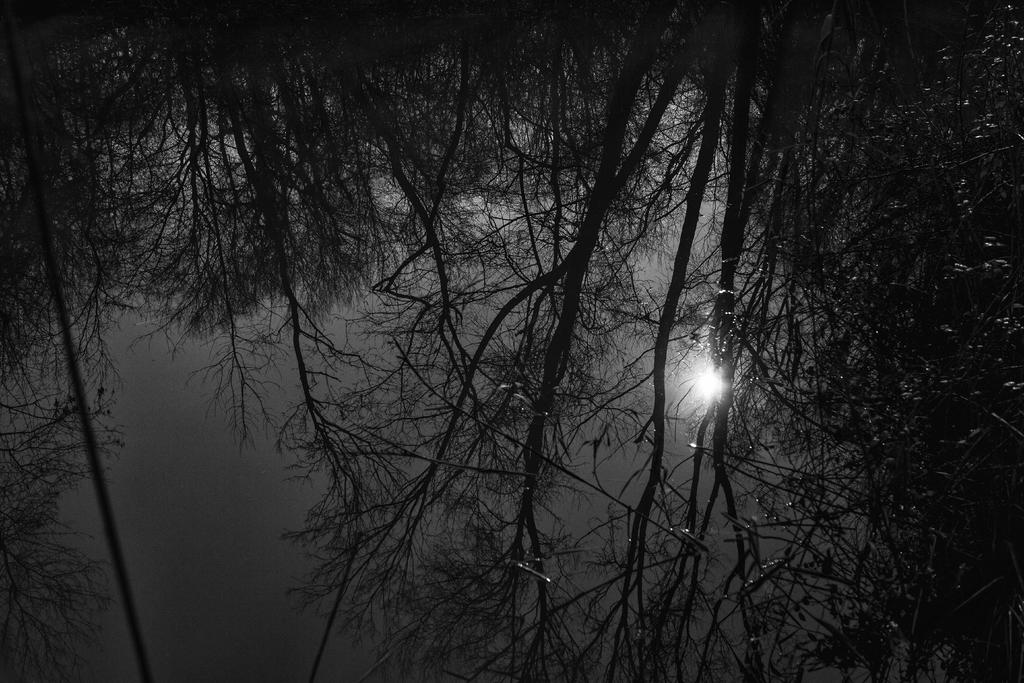What type of vegetation is present in the image? There are many trees in the image. What celestial body can be seen in the sky? The moon is visible in the sky. Can you describe the time of day when the image was taken? The image appears to be taken at night time. What type of shoe is hanging from the tree in the image? There is no shoe present in the image; it only features trees and the moon in the sky. 